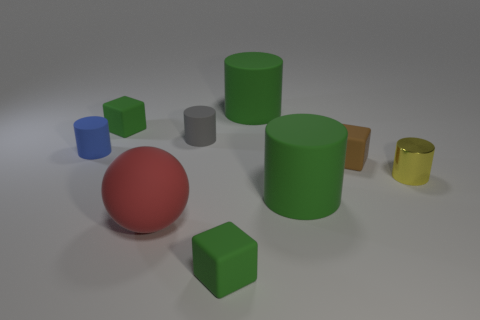What number of purple metal objects are the same size as the gray rubber cylinder?
Offer a terse response. 0. The tiny green thing that is on the left side of the green matte block in front of the tiny yellow thing is what shape?
Provide a short and direct response. Cube. The small green matte object that is right of the tiny green rubber object that is behind the yellow object on the right side of the brown cube is what shape?
Provide a succinct answer. Cube. What number of green objects have the same shape as the red thing?
Make the answer very short. 0. How many green rubber things are in front of the large rubber cylinder in front of the tiny yellow cylinder?
Offer a very short reply. 1. What number of rubber things are either tiny gray things or tiny brown objects?
Your answer should be very brief. 2. Is there a gray object that has the same material as the big red sphere?
Make the answer very short. Yes. What number of objects are green things that are behind the small yellow object or large green matte objects in front of the small blue rubber thing?
Provide a succinct answer. 3. How many other objects are there of the same color as the large ball?
Provide a succinct answer. 0. What is the yellow object made of?
Your answer should be very brief. Metal. 